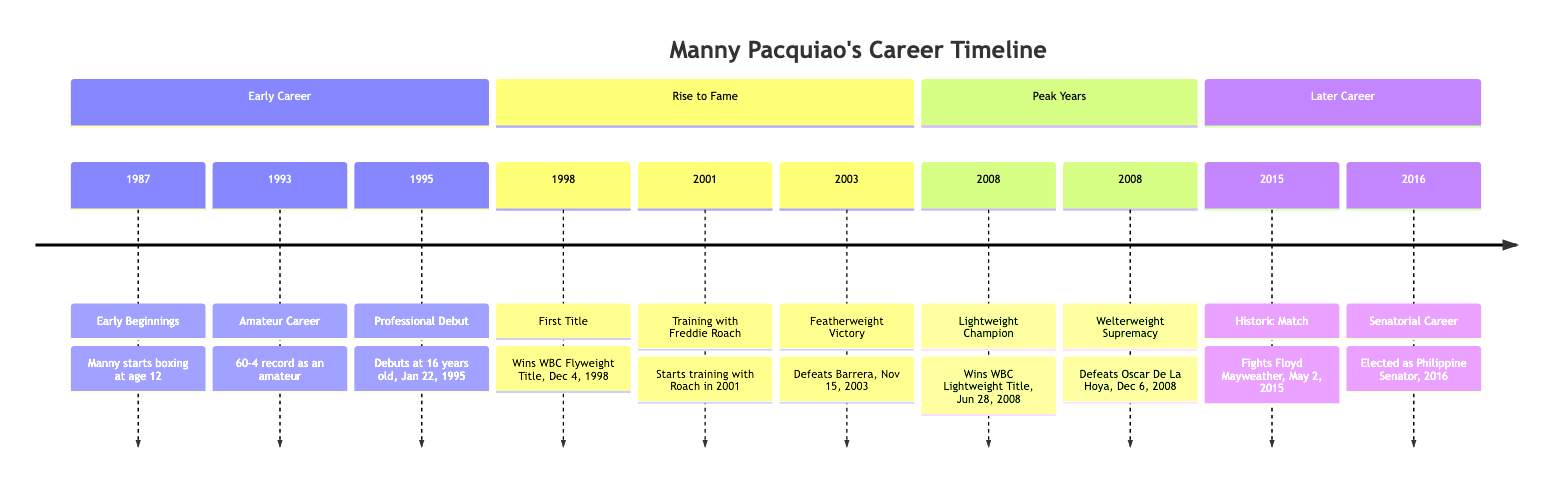What year did Manny Pacquiao start boxing? The diagram states that Manny started boxing in 1987, at age 12.
Answer: 1987 What was Manny Pacquiao's amateur record? According to the diagram, his amateur record was 60 wins and 4 losses.
Answer: 60-4 What major title did Manny Pacquiao win in 1998? The diagram highlights that he won the WBC Flyweight Title on December 4, 1998.
Answer: WBC Flyweight Title Which trainer did Manny Pacquiao start working with in 2001? The timeline section indicates that he began training with Freddie Roach in 2001.
Answer: Freddie Roach In which year did Manny defeat Oscar De La Hoya? The diagram shows that he defeated Oscar De La Hoya on December 6, 2008.
Answer: 2008 What significant life event occurred for Manny Pacquiao in 2016? The diagram states that he was elected as a Philippine Senator in 2016, marking a significant pivot in his career.
Answer: Elected as Philippine Senator How many sections are there in Manny Pacquiao's Career Timeline? The diagram is divided into four sections: Early Career, Rise to Fame, Peak Years, and Later Career.
Answer: 4 What milestone event happened on May 2, 2015, in Manny Pacquiao's career? According to the diagram, he fought Floyd Mayweather on that date, which was a historic match.
Answer: Fought Floyd Mayweather What year marks Manny Pacquiao's professional debut? The diagram indicates that his professional debut took place on January 22, 1995.
Answer: 1995 